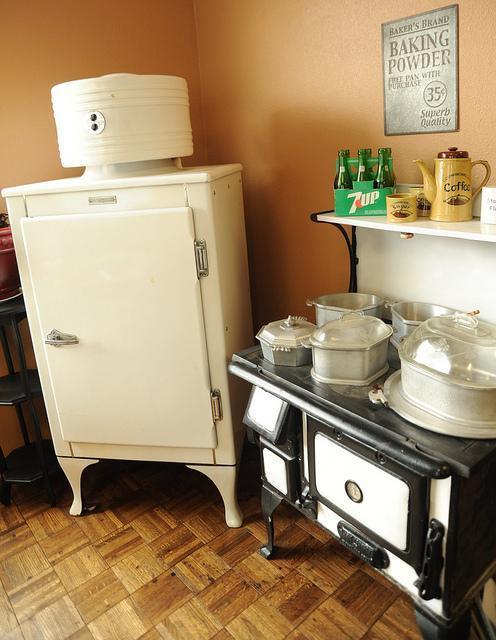How many elephants are standing up in the water?
Give a very brief answer. 0. 